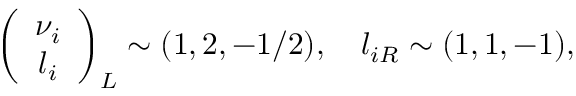<formula> <loc_0><loc_0><loc_500><loc_500>\left ( \begin{array} { c } { { \nu _ { i } } } \\ { { l _ { i } } } \end{array} \right ) _ { L } \sim ( 1 , 2 , - 1 / 2 ) , l _ { i R } \sim ( 1 , 1 , - 1 ) ,</formula> 